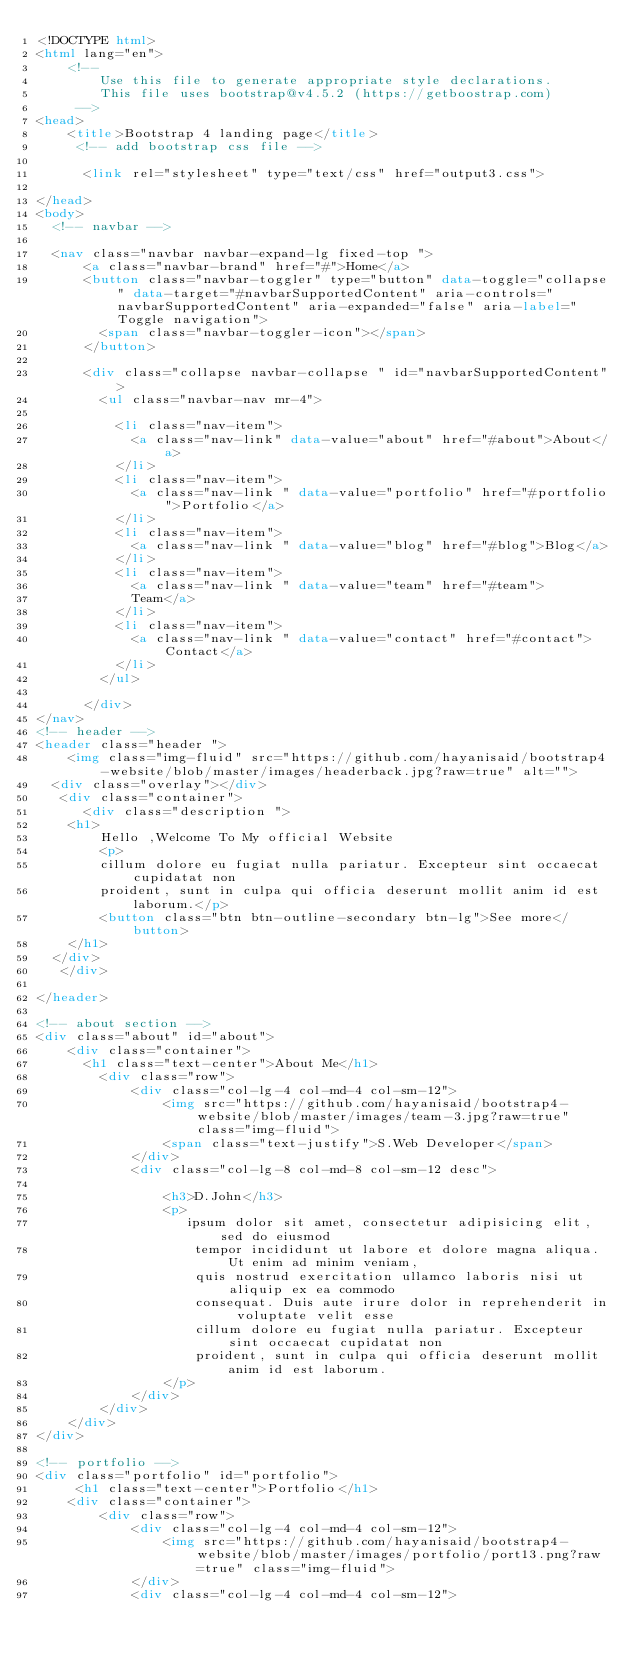<code> <loc_0><loc_0><loc_500><loc_500><_HTML_><!DOCTYPE html>
<html lang="en">
    <!-- 
        Use this file to generate appropriate style declarations.
        This file uses bootstrap@v4.5.2 (https://getboostrap.com)
     -->
<head>
	<title>Bootstrap 4 landing page</title>
	 <!-- add bootstrap css file -->

      <link rel="stylesheet" type="text/css" href="output3.css">
      
</head>
<body>
  <!-- navbar -->

  <nav class="navbar navbar-expand-lg fixed-top ">
	  <a class="navbar-brand" href="#">Home</a>
	  <button class="navbar-toggler" type="button" data-toggle="collapse" data-target="#navbarSupportedContent" aria-controls="navbarSupportedContent" aria-expanded="false" aria-label="Toggle navigation">
	    <span class="navbar-toggler-icon"></span>
	  </button>

	  <div class="collapse navbar-collapse " id="navbarSupportedContent">
	    <ul class="navbar-nav mr-4">
	      
	      <li class="nav-item">
	        <a class="nav-link" data-value="about" href="#about">About</a>
	      </li>
	      <li class="nav-item">
	        <a class="nav-link " data-value="portfolio" href="#portfolio">Portfolio</a>
	      </li>
	      <li class="nav-item">
	        <a class="nav-link " data-value="blog" href="#blog">Blog</a>
	      </li>
	      <li class="nav-item">
	        <a class="nav-link " data-value="team" href="#team">
	        Team</a>
	      </li>
	      <li class="nav-item">
	        <a class="nav-link " data-value="contact" href="#contact">Contact</a>
	      </li>
	    </ul>
	    
	  </div>
</nav>
<!-- header -->
<header class="header ">
    <img class="img-fluid" src="https://github.com/hayanisaid/bootstrap4-website/blob/master/images/headerback.jpg?raw=true" alt="">
  <div class="overlay"></div>
   <div class="container">
   	  <div class="description ">
  	<h1>
  		Hello ,Welcome To My official Website
  		<p>
  		cillum dolore eu fugiat nulla pariatur. Excepteur sint occaecat cupidatat non
  		proident, sunt in culpa qui officia deserunt mollit anim id est laborum.</p>
  		<button class="btn btn-outline-secondary btn-lg">See more</button>
  	</h1>
  </div>
   </div>
  
</header>

<!-- about section -->
<div class="about" id="about">
	<div class="container">
	  <h1 class="text-center">About Me</h1>
		<div class="row">
			<div class="col-lg-4 col-md-4 col-sm-12">
				<img src="https://github.com/hayanisaid/bootstrap4-website/blob/master/images/team-3.jpg?raw=true" class="img-fluid">
				<span class="text-justify">S.Web Developer</span>
			</div>
			<div class="col-lg-8 col-md-8 col-sm-12 desc">
			  
				<h3>D.John</h3>
				<p>
				   ipsum dolor sit amet, consectetur adipisicing elit, sed do eiusmod
					tempor incididunt ut labore et dolore magna aliqua. Ut enim ad minim veniam,
					quis nostrud exercitation ullamco laboris nisi ut aliquip ex ea commodo
					consequat. Duis aute irure dolor in reprehenderit in voluptate velit esse
					cillum dolore eu fugiat nulla pariatur. Excepteur sint occaecat cupidatat non
					proident, sunt in culpa qui officia deserunt mollit anim id est laborum.
				</p>
			</div>
		</div>
	</div>
</div>

<!-- portfolio -->
<div class="portfolio" id="portfolio">
     <h1 class="text-center">Portfolio</h1>
	<div class="container">
		<div class="row">
			<div class="col-lg-4 col-md-4 col-sm-12">
				<img src="https://github.com/hayanisaid/bootstrap4-website/blob/master/images/portfolio/port13.png?raw=true" class="img-fluid">
			</div>
			<div class="col-lg-4 col-md-4 col-sm-12"></code> 